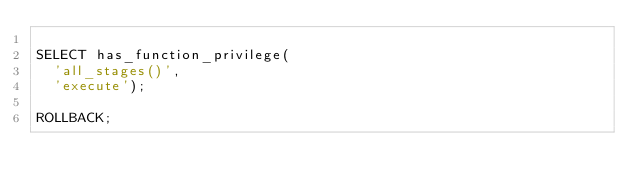<code> <loc_0><loc_0><loc_500><loc_500><_SQL_>
SELECT has_function_privilege(
  'all_stages()',
  'execute');

ROLLBACK;
</code> 